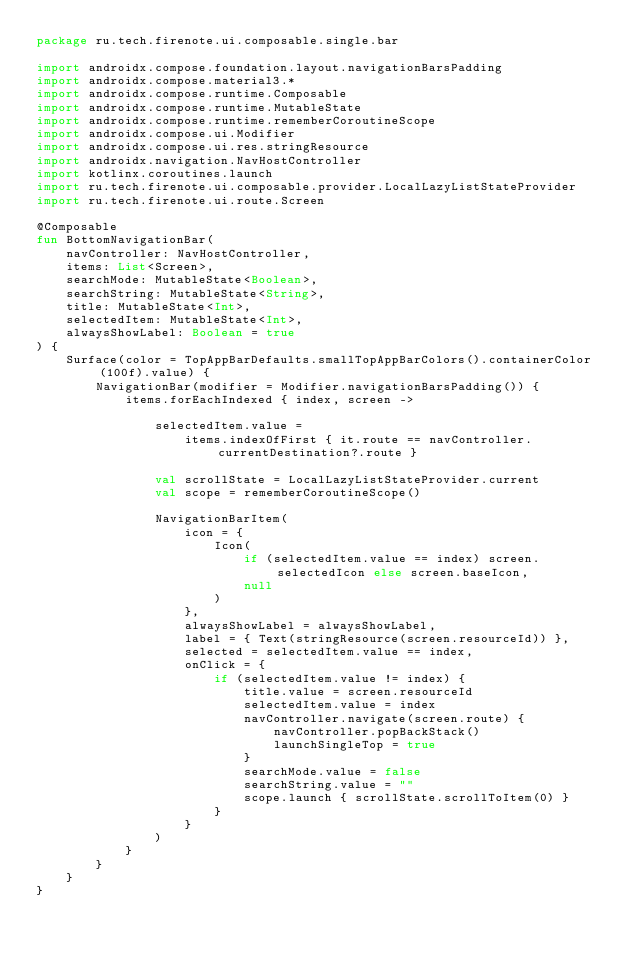Convert code to text. <code><loc_0><loc_0><loc_500><loc_500><_Kotlin_>package ru.tech.firenote.ui.composable.single.bar

import androidx.compose.foundation.layout.navigationBarsPadding
import androidx.compose.material3.*
import androidx.compose.runtime.Composable
import androidx.compose.runtime.MutableState
import androidx.compose.runtime.rememberCoroutineScope
import androidx.compose.ui.Modifier
import androidx.compose.ui.res.stringResource
import androidx.navigation.NavHostController
import kotlinx.coroutines.launch
import ru.tech.firenote.ui.composable.provider.LocalLazyListStateProvider
import ru.tech.firenote.ui.route.Screen

@Composable
fun BottomNavigationBar(
    navController: NavHostController,
    items: List<Screen>,
    searchMode: MutableState<Boolean>,
    searchString: MutableState<String>,
    title: MutableState<Int>,
    selectedItem: MutableState<Int>,
    alwaysShowLabel: Boolean = true
) {
    Surface(color = TopAppBarDefaults.smallTopAppBarColors().containerColor(100f).value) {
        NavigationBar(modifier = Modifier.navigationBarsPadding()) {
            items.forEachIndexed { index, screen ->

                selectedItem.value =
                    items.indexOfFirst { it.route == navController.currentDestination?.route }

                val scrollState = LocalLazyListStateProvider.current
                val scope = rememberCoroutineScope()

                NavigationBarItem(
                    icon = {
                        Icon(
                            if (selectedItem.value == index) screen.selectedIcon else screen.baseIcon,
                            null
                        )
                    },
                    alwaysShowLabel = alwaysShowLabel,
                    label = { Text(stringResource(screen.resourceId)) },
                    selected = selectedItem.value == index,
                    onClick = {
                        if (selectedItem.value != index) {
                            title.value = screen.resourceId
                            selectedItem.value = index
                            navController.navigate(screen.route) {
                                navController.popBackStack()
                                launchSingleTop = true
                            }
                            searchMode.value = false
                            searchString.value = ""
                            scope.launch { scrollState.scrollToItem(0) }
                        }
                    }
                )
            }
        }
    }
}</code> 